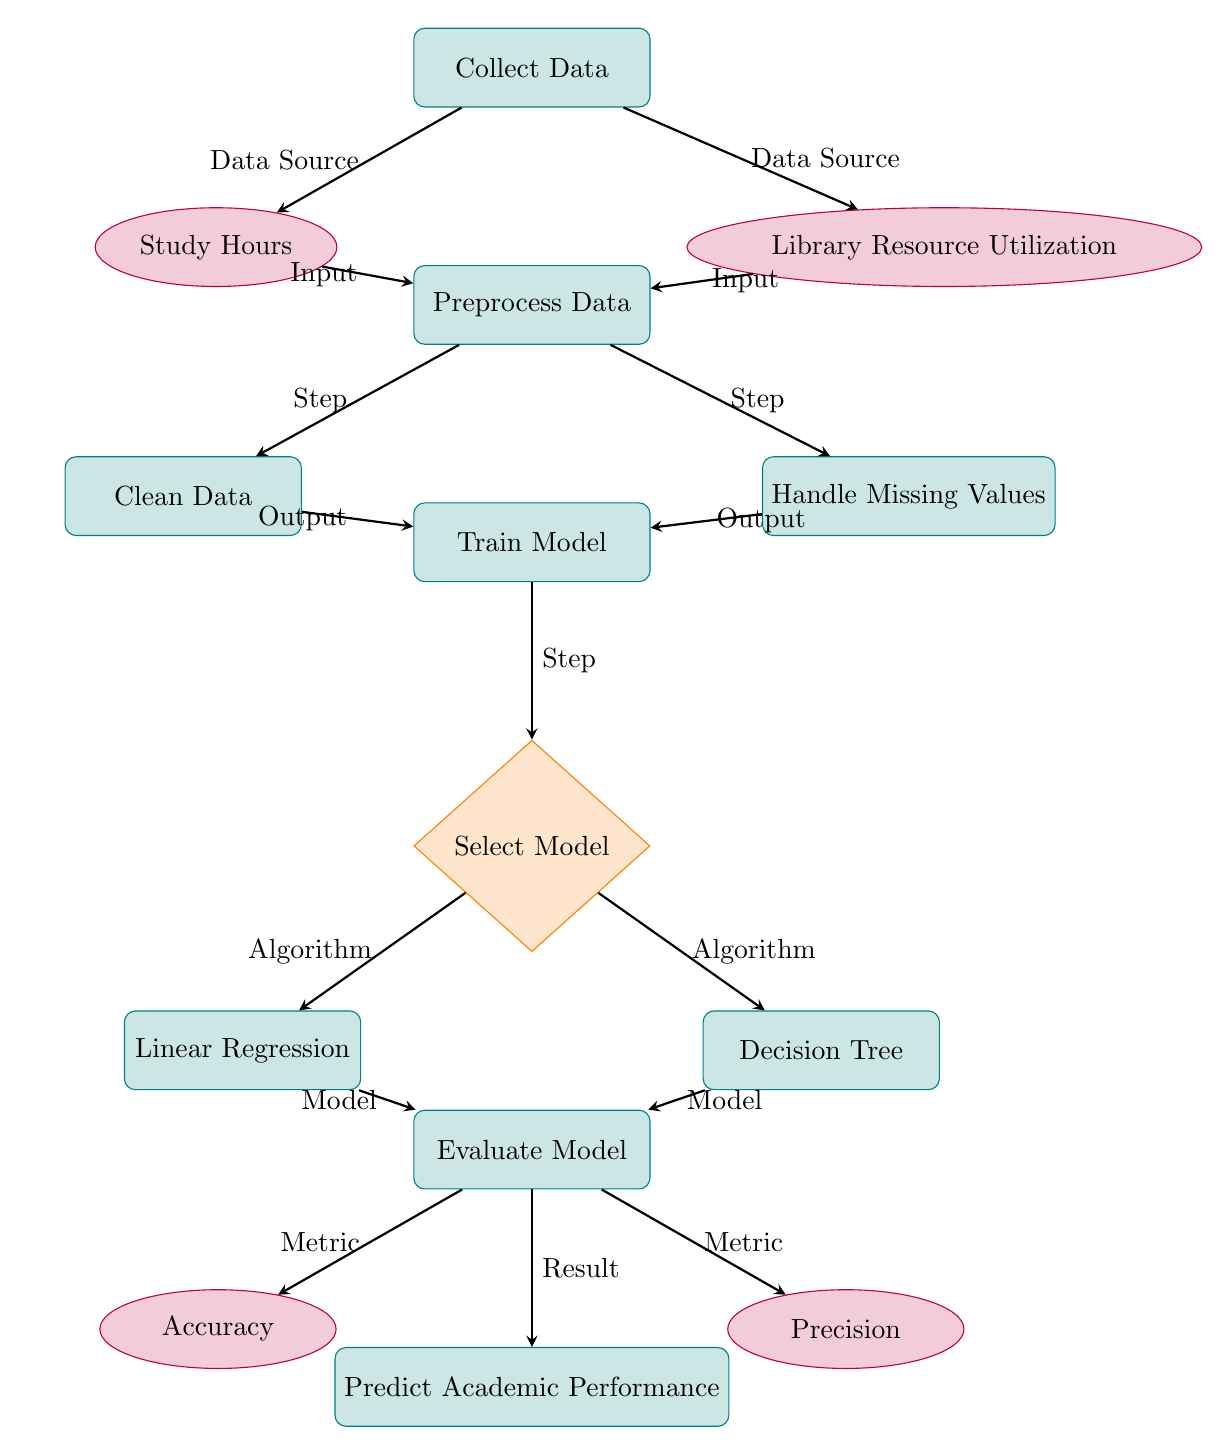What is the first process in the diagram? The first process node is labeled "Collect Data," which is the starting point of the data flow in the diagram.
Answer: Collect Data How many data nodes are in the diagram? The diagram contains three data nodes: "Study Hours," "Library Resource Utilization," and "Accuracy." To find the number, we can count each data node presented in the diagram.
Answer: Three Which process follows "Preprocess Data"? After "Preprocess Data," the next process node is "Train Model." This can be observed as a direct downstream process flow from "Preprocess Data."
Answer: Train Model What type of decision node is present in the diagram? The decision node present in the diagram is labeled "Select Model," which requires choosing among different model algorithms based on evaluation criteria.
Answer: Select Model What are the two algorithms selected at the "Select Model" decision node? The two algorithms indicated are "Linear Regression" and "Decision Tree." These options are directly connected to the "Select Model" decision node as potential choices.
Answer: Linear Regression and Decision Tree How many output metrics are evaluated after the model training? There are two output metrics evaluated after the model training: "Accuracy" and "Precision." These are shown as the outputs of the "Evaluate Model" process node.
Answer: Two What is the final process in the flow of the diagram? The final process in the flow is "Predict Academic Performance," which follows the evaluation of the model and signifies the conclusion of the analysis.
Answer: Predict Academic Performance Where do "Study Hours" and "Library Resource Utilization" feed into? Both "Study Hours" and "Library Resource Utilization" feed into the "Preprocess Data" process. This shows that the collected data from these inputs is prepared for use in model training.
Answer: Preprocess Data What is the primary goal of the diagram? The primary goal of the diagram is to illustrate the process of "Predicting Academic Performance" using study hours and resource utilization, showcasing the steps between data collection and prediction.
Answer: Predicting Academic Performance 